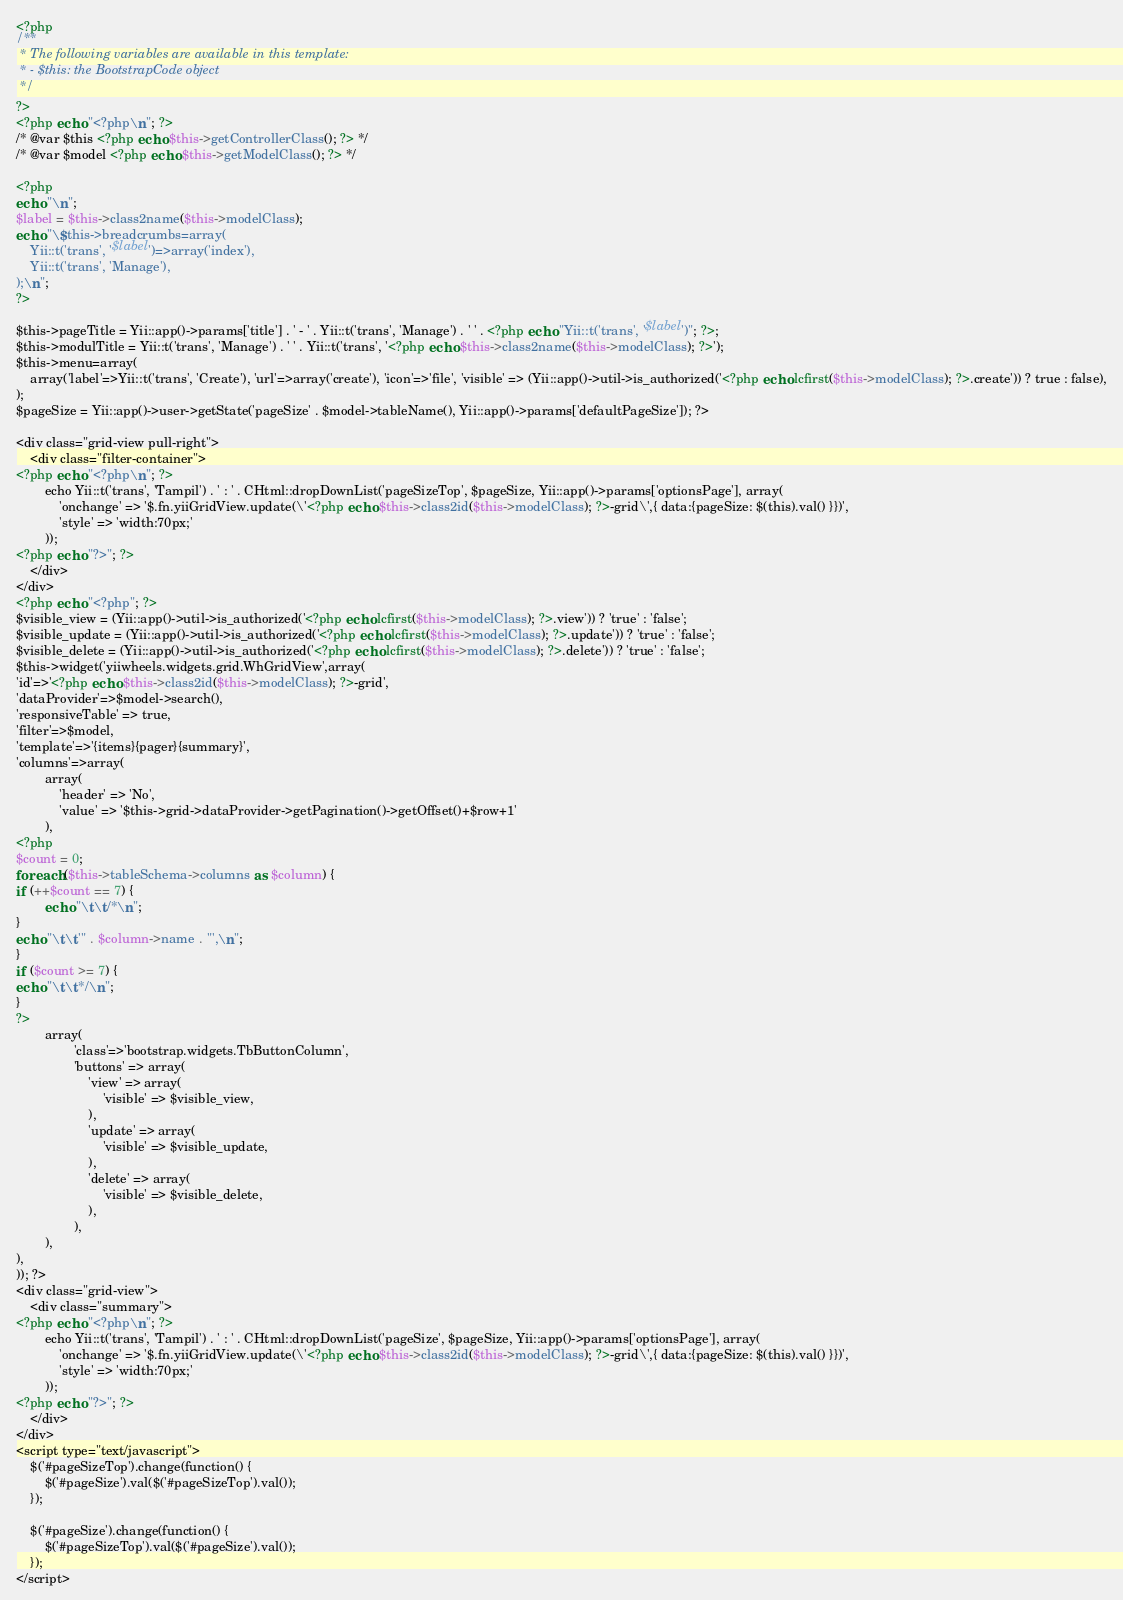Convert code to text. <code><loc_0><loc_0><loc_500><loc_500><_PHP_><?php
/**
 * The following variables are available in this template:
 * - $this: the BootstrapCode object
 */
?>
<?php echo "<?php\n"; ?>
/* @var $this <?php echo $this->getControllerClass(); ?> */
/* @var $model <?php echo $this->getModelClass(); ?> */

<?php
echo "\n";
$label = $this->class2name($this->modelClass);
echo "\$this->breadcrumbs=array(
	Yii::t('trans', '$label')=>array('index'),
	Yii::t('trans', 'Manage'),
);\n";
?>

$this->pageTitle = Yii::app()->params['title'] . ' - ' . Yii::t('trans', 'Manage') . ' ' . <?php echo "Yii::t('trans', '$label')"; ?>;
$this->modulTitle = Yii::t('trans', 'Manage') . ' ' . Yii::t('trans', '<?php echo $this->class2name($this->modelClass); ?>');
$this->menu=array(
	array('label'=>Yii::t('trans', 'Create'), 'url'=>array('create'), 'icon'=>'file', 'visible' => (Yii::app()->util->is_authorized('<?php echo lcfirst($this->modelClass); ?>.create')) ? true : false),
);
$pageSize = Yii::app()->user->getState('pageSize' . $model->tableName(), Yii::app()->params['defaultPageSize']); ?>

<div class="grid-view pull-right">
    <div class="filter-container">
<?php echo "<?php\n"; ?>
        echo Yii::t('trans', 'Tampil') . ' : ' . CHtml::dropDownList('pageSizeTop', $pageSize, Yii::app()->params['optionsPage'], array(
            'onchange' => '$.fn.yiiGridView.update(\'<?php echo $this->class2id($this->modelClass); ?>-grid\',{ data:{pageSize: $(this).val() }})',
            'style' => 'width:70px;'
        ));        
<?php echo "?>"; ?>
    </div>
</div>
<?php echo "<?php"; ?> 
$visible_view = (Yii::app()->util->is_authorized('<?php echo lcfirst($this->modelClass); ?>.view')) ? 'true' : 'false';
$visible_update = (Yii::app()->util->is_authorized('<?php echo lcfirst($this->modelClass); ?>.update')) ? 'true' : 'false';
$visible_delete = (Yii::app()->util->is_authorized('<?php echo lcfirst($this->modelClass); ?>.delete')) ? 'true' : 'false';
$this->widget('yiiwheels.widgets.grid.WhGridView',array(
'id'=>'<?php echo $this->class2id($this->modelClass); ?>-grid',
'dataProvider'=>$model->search(),
'responsiveTable' => true,
'filter'=>$model,
'template'=>'{items}{pager}{summary}', 
'columns'=>array(
        array(
            'header' => 'No',
            'value' => '$this->grid->dataProvider->getPagination()->getOffset()+$row+1'
        ),
<?php
$count = 0;
foreach ($this->tableSchema->columns as $column) {
if (++$count == 7) {
        echo "\t\t/*\n";
}
echo "\t\t'" . $column->name . "',\n";
}
if ($count >= 7) {
echo "\t\t*/\n";
}
?>
        array(
                'class'=>'bootstrap.widgets.TbButtonColumn',
                'buttons' => array(
                    'view' => array(
                        'visible' => $visible_view, 
                    ),
                    'update' => array(
                        'visible' => $visible_update, 
                    ),
                    'delete' => array(
                        'visible' => $visible_delete, 
                    ),
                ),
        ),
),
)); ?>
<div class="grid-view">
    <div class="summary">
<?php echo "<?php\n"; ?>
        echo Yii::t('trans', 'Tampil') . ' : ' . CHtml::dropDownList('pageSize', $pageSize, Yii::app()->params['optionsPage'], array(
            'onchange' => '$.fn.yiiGridView.update(\'<?php echo $this->class2id($this->modelClass); ?>-grid\',{ data:{pageSize: $(this).val() }})',
            'style' => 'width:70px;'
        ));        
<?php echo "?>"; ?>
    </div>
</div>  
<script type="text/javascript">    
    $('#pageSizeTop').change(function() {
        $('#pageSize').val($('#pageSizeTop').val());
    });

    $('#pageSize').change(function() {
        $('#pageSizeTop').val($('#pageSize').val());
    });
</script></code> 